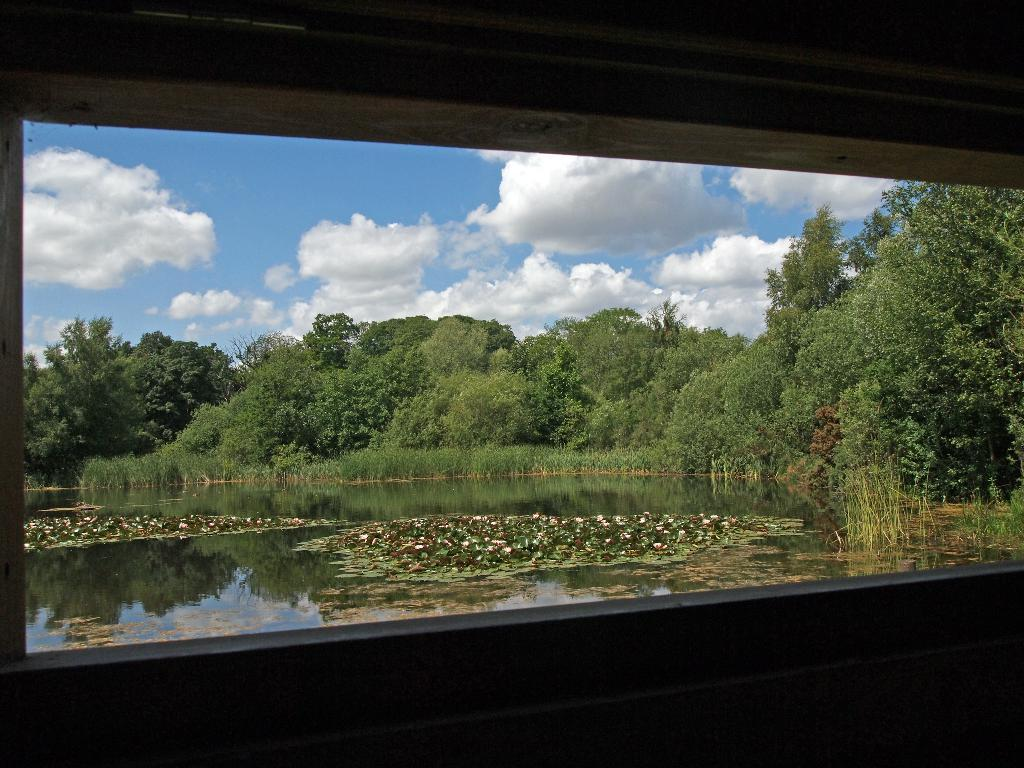What can be seen through the window in the image? The sky with clouds, trees, and water are visible through the window. What is present on the water? Flowers and leaves are present on the water. What type of rhythm can be heard coming from the sticks in the image? There are no sticks present in the image, so it is not possible to determine any rhythm. 